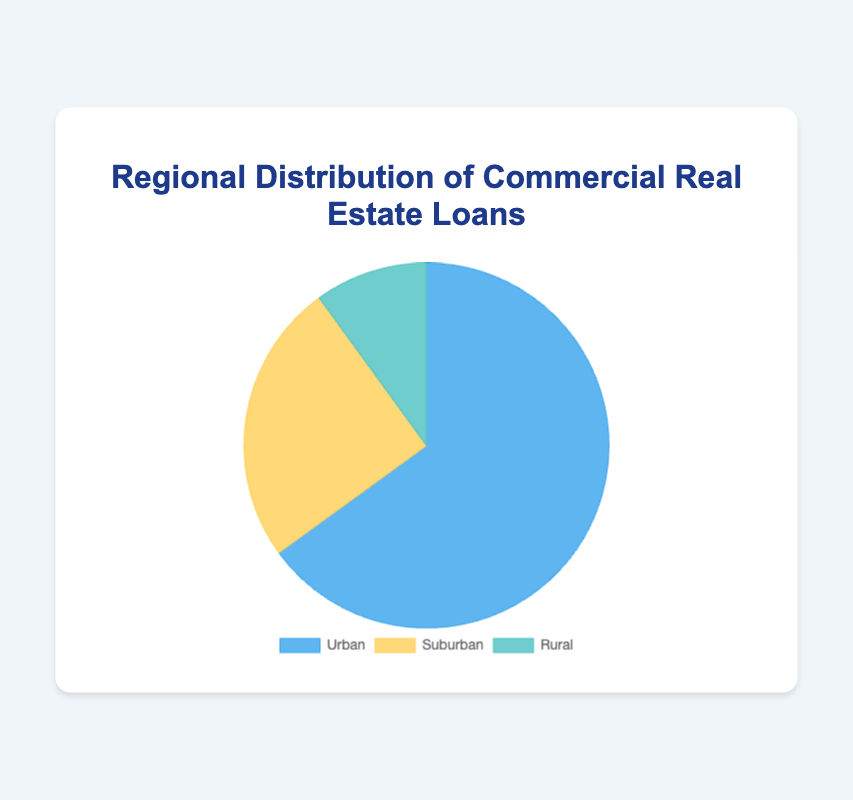Which region has the highest percentage of commercial real estate loans? The figure shows three segments representing Urban, Suburban, and Rural regions. The segment with the largest area corresponds to Urban with 65%.
Answer: Urban How much greater is the percentage of Urban loans compared to Rural loans? The percentage of Urban loans is 65%, and Rural loans is 10%. Subtracting the Rural percentage from the Urban percentage: 65% - 10% equals 55%.
Answer: 55% What is the combined percentage of Suburban and Rural loans? The Suburban region represents 25%, and the Rural region represents 10%. Adding them gives: 25% + 10% equals 35%.
Answer: 35% Which region has the least percentage of loans and what is that percentage? The smallest segment in the pie chart represents the Rural region which has 10%.
Answer: Rural, 10% Compare the percentages of loans in Urban and Suburban regions. The pie chart shows Urban loans at 65% and Suburban loans at 25%. Urban has a higher percentage compared to Suburban.
Answer: Urban has 40% more than Suburban Are Urban and Suburban combined percentages higher than Rural? Urban and Suburban combined are 65% + 25% which equals 90%, while Rural is 10%. 90% is greater than 10%.
Answer: Yes What color represents the Suburban region in the pie chart? In the pie chart, the Suburban region segment is colored yellow.
Answer: Yellow If the percentages were doubled, what would the new percentage be for the Rural region? Doubling the Rural region's percentage of 10% results in 10% * 2 equals 20%.
Answer: 20% Which two regions combined make up 75% of the total loan distribution? The Urban region is 65% and Suburban region is 25%. Combining these two: 65% + 25% equals 90%, but combining Urban and Rural: 65% + 10% equals 75%.
Answer: Urban and Rural How do the Urban and Suburban loan percentages compare visually? Visually, the Urban segment is much larger than the Suburban segment, indicating a significantly higher percentage.
Answer: Urban is much larger than Suburban 